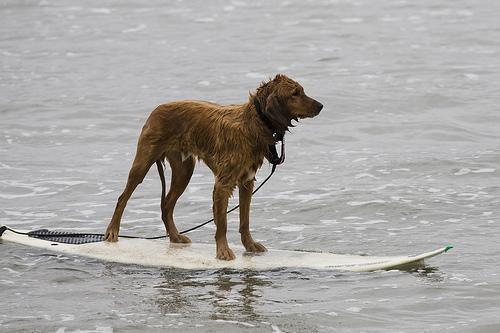How many dogs are there?
Give a very brief answer. 1. How many of the dog's feet are touching a black part of the surfboard?
Give a very brief answer. 1. 